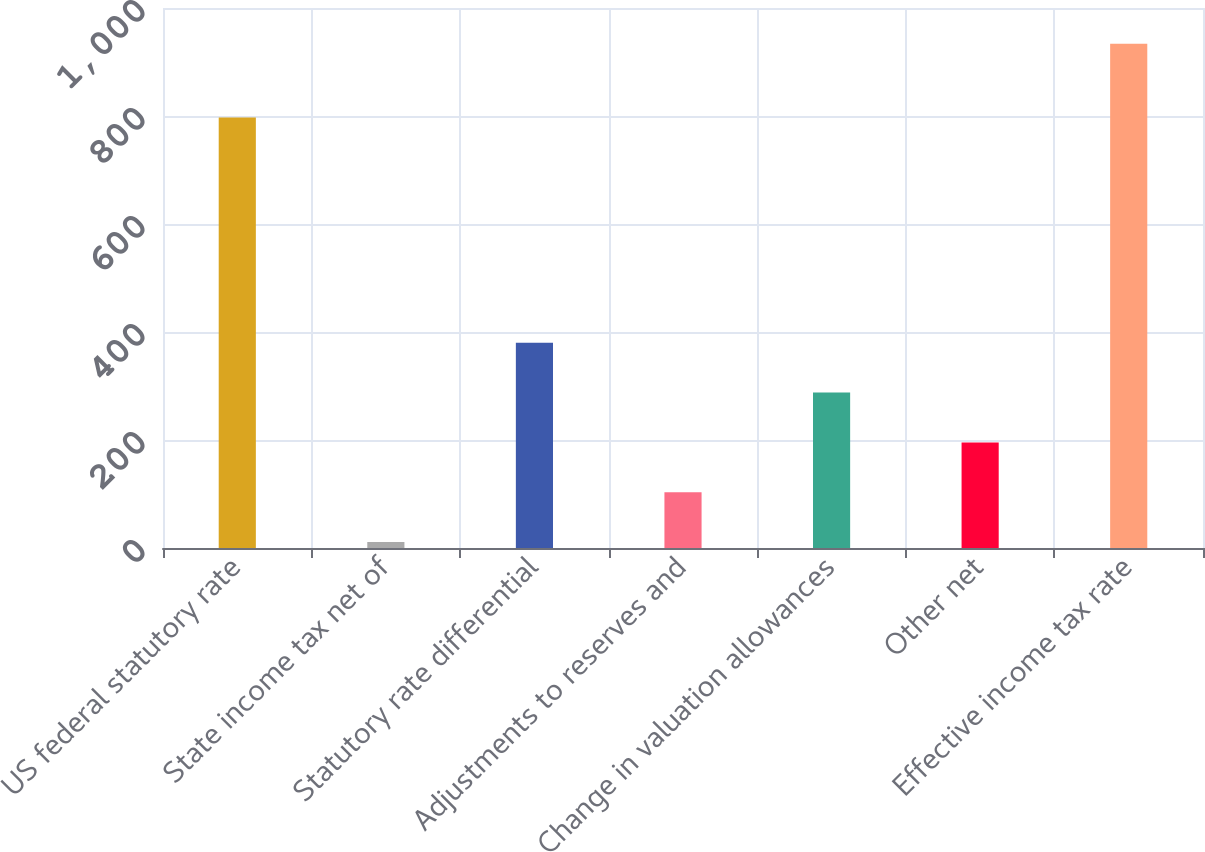<chart> <loc_0><loc_0><loc_500><loc_500><bar_chart><fcel>US federal statutory rate<fcel>State income tax net of<fcel>Statutory rate differential<fcel>Adjustments to reserves and<fcel>Change in valuation allowances<fcel>Other net<fcel>Effective income tax rate<nl><fcel>797<fcel>11<fcel>380.2<fcel>103.3<fcel>287.9<fcel>195.6<fcel>934<nl></chart> 